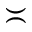Convert formula to latex. <formula><loc_0><loc_0><loc_500><loc_500>\asymp</formula> 